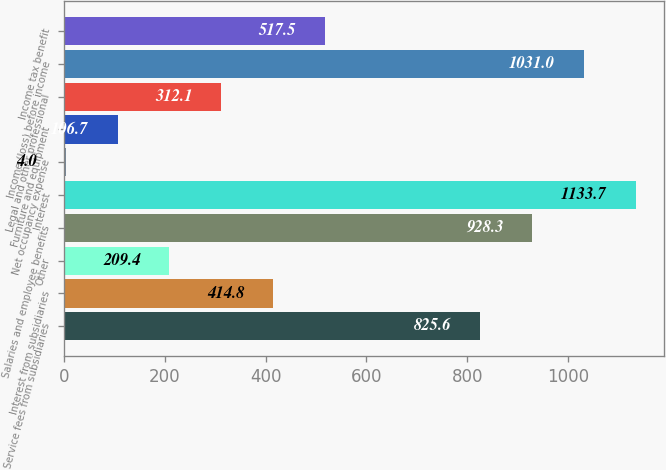Convert chart to OTSL. <chart><loc_0><loc_0><loc_500><loc_500><bar_chart><fcel>Service fees from subsidiaries<fcel>Interest from subsidiaries<fcel>Other<fcel>Salaries and employee benefits<fcel>Interest<fcel>Net occupancy expense<fcel>Furniture and equipment<fcel>Legal and other professional<fcel>Income (loss) before income<fcel>Income tax benefit<nl><fcel>825.6<fcel>414.8<fcel>209.4<fcel>928.3<fcel>1133.7<fcel>4<fcel>106.7<fcel>312.1<fcel>1031<fcel>517.5<nl></chart> 